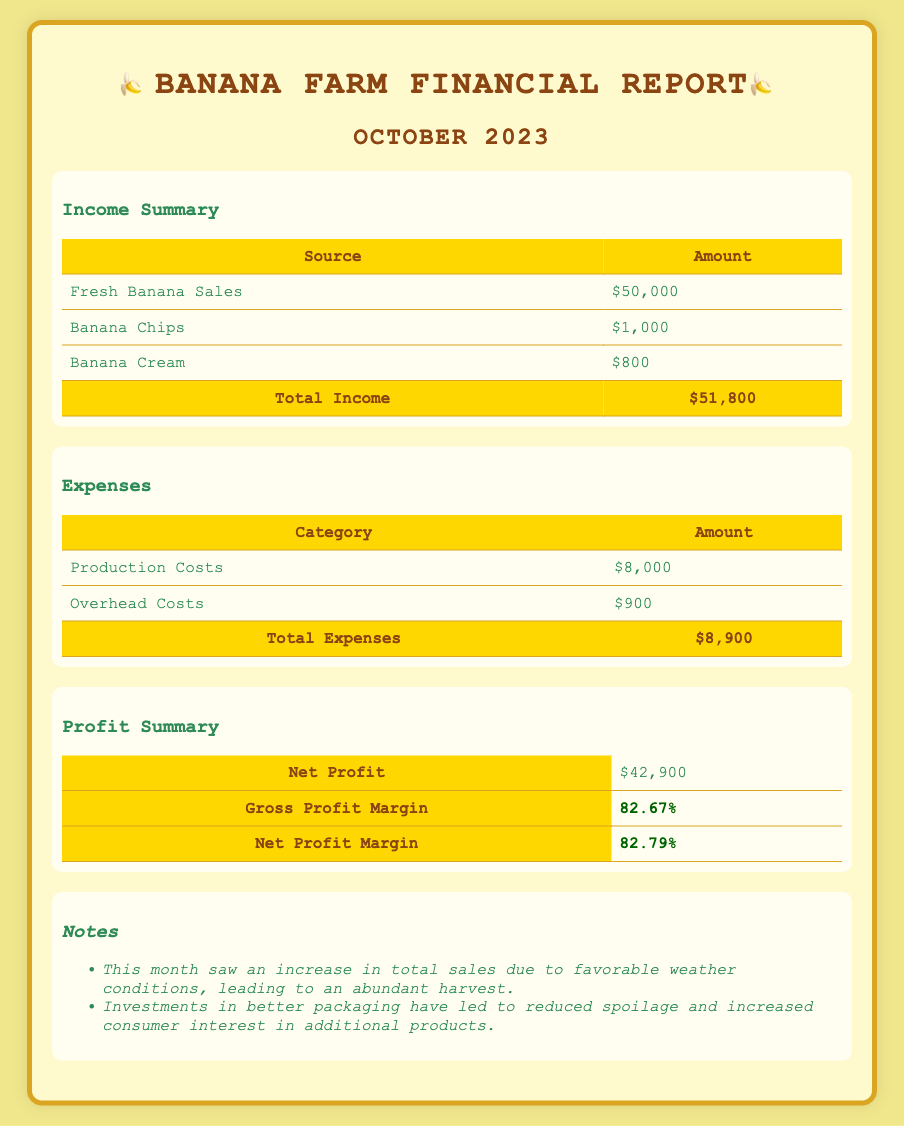What is the total income? The total income is detailed in the income summary section, which combines all revenue sources.
Answer: $51,800 What are the production costs? Production costs are listed under expenses, detailing the direct costs associated with producing bananas.
Answer: $8,000 What is the net profit margin? The net profit margin is provided in the profit summary section and represents profit as a percentage of total income.
Answer: 82.79% What contributed to the increase in total sales this month? The notes section details reasons for increased sales, including weather conditions and packaging improvements.
Answer: Favorable weather conditions What is the total amount of banana chips sales? The document specifies the revenue generated from banana chips sales under income summary.
Answer: $1,000 What is the total expenses amount? The total expenses are calculated by summing the listed expense categories in the expenses section.
Answer: $8,900 How much is the gross profit margin? The gross profit margin is presented in the profit summary section, indicating the ratio of gross profit to total income.
Answer: 82.67% What is the category of the highest expense? The expenses section lists various categories, with production costs being the highest.
Answer: Production Costs 